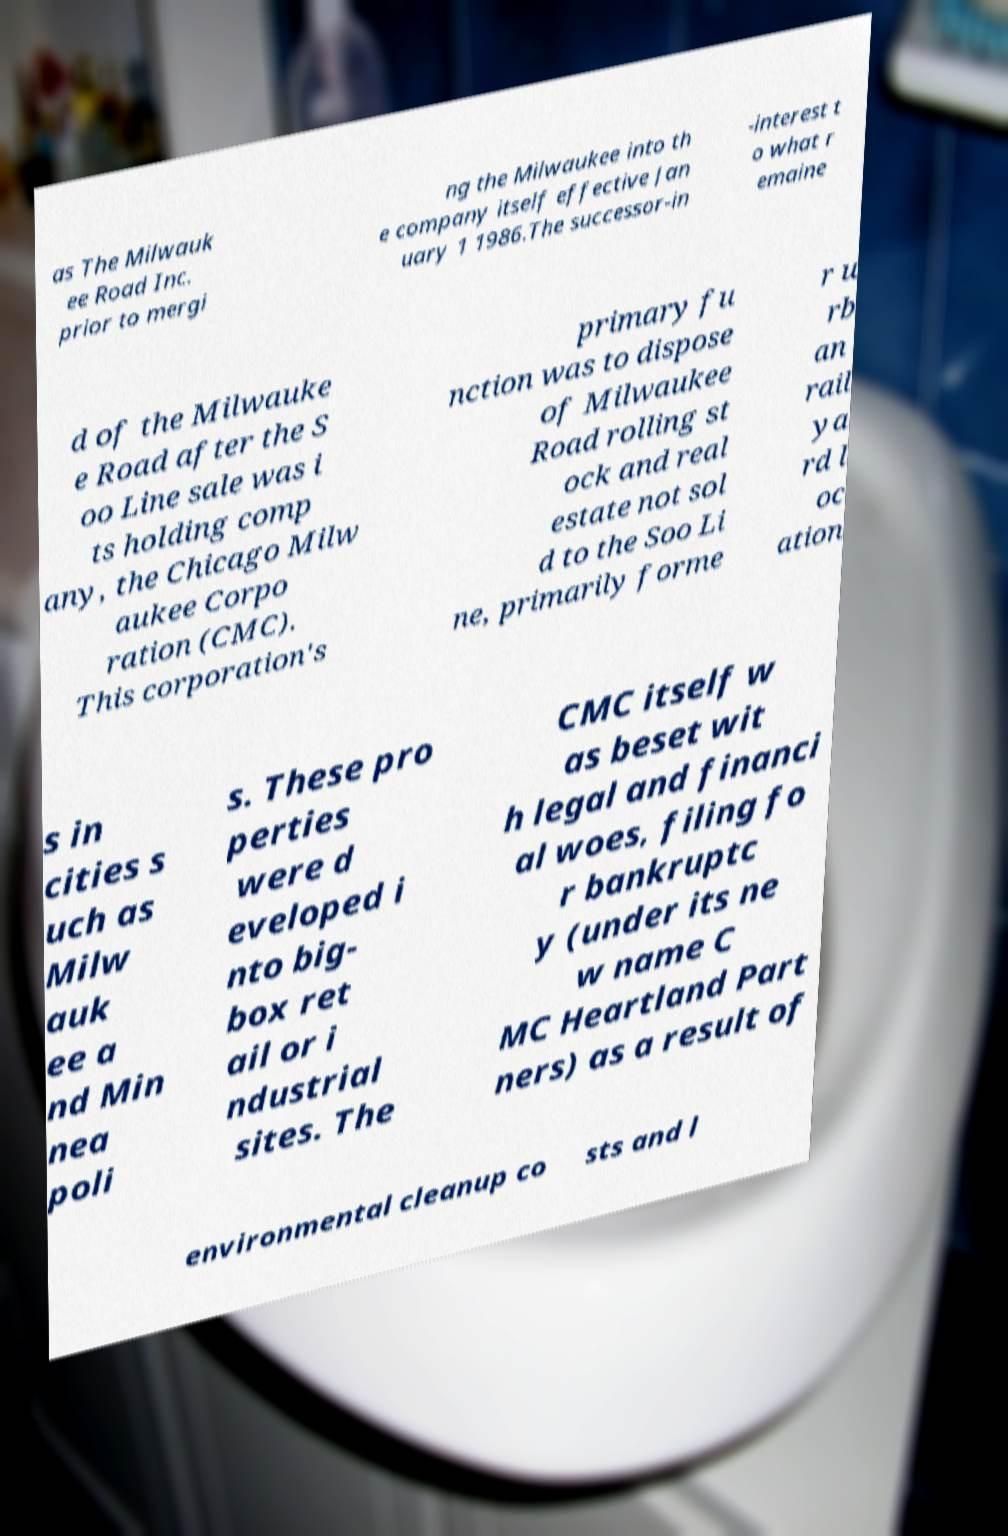For documentation purposes, I need the text within this image transcribed. Could you provide that? as The Milwauk ee Road Inc. prior to mergi ng the Milwaukee into th e company itself effective Jan uary 1 1986.The successor-in -interest t o what r emaine d of the Milwauke e Road after the S oo Line sale was i ts holding comp any, the Chicago Milw aukee Corpo ration (CMC). This corporation's primary fu nction was to dispose of Milwaukee Road rolling st ock and real estate not sol d to the Soo Li ne, primarily forme r u rb an rail ya rd l oc ation s in cities s uch as Milw auk ee a nd Min nea poli s. These pro perties were d eveloped i nto big- box ret ail or i ndustrial sites. The CMC itself w as beset wit h legal and financi al woes, filing fo r bankruptc y (under its ne w name C MC Heartland Part ners) as a result of environmental cleanup co sts and l 